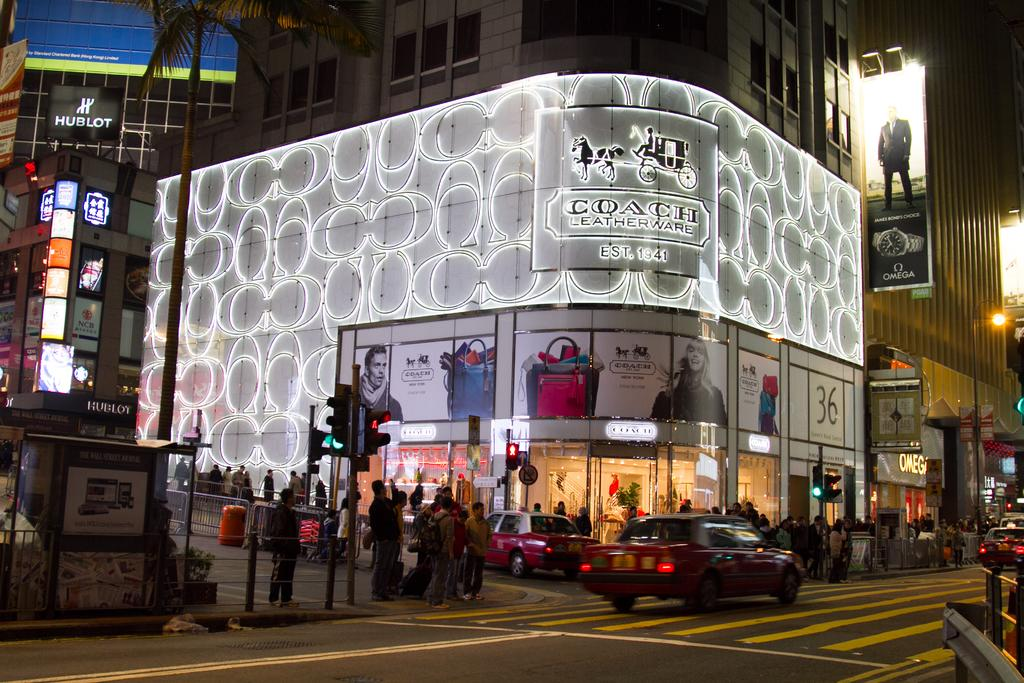<image>
Provide a brief description of the given image. The entrance to the Coach store on the corner of a busy street. 